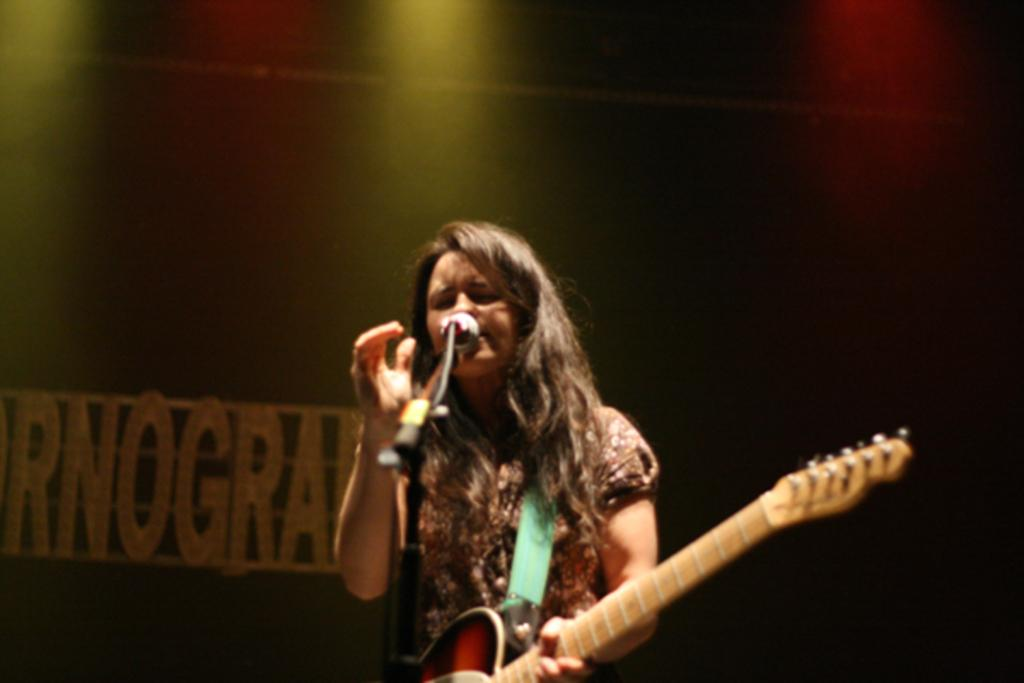Who is the main subject in the image? There is a woman in the image. What is the woman doing in the image? The woman is standing, holding a guitar, and singing in front of a microphone. What is the woman holding in her hands? The woman is holding a guitar. What is written on the stage behind the woman? There is text written on the stage behind the woman. What type of coach can be seen in the image? There is no coach present in the image. What type of poison is the woman using in the image? There is no poison present in the image; the woman is singing with a guitar and microphone. 